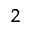Convert formula to latex. <formula><loc_0><loc_0><loc_500><loc_500>^ { 2 }</formula> 